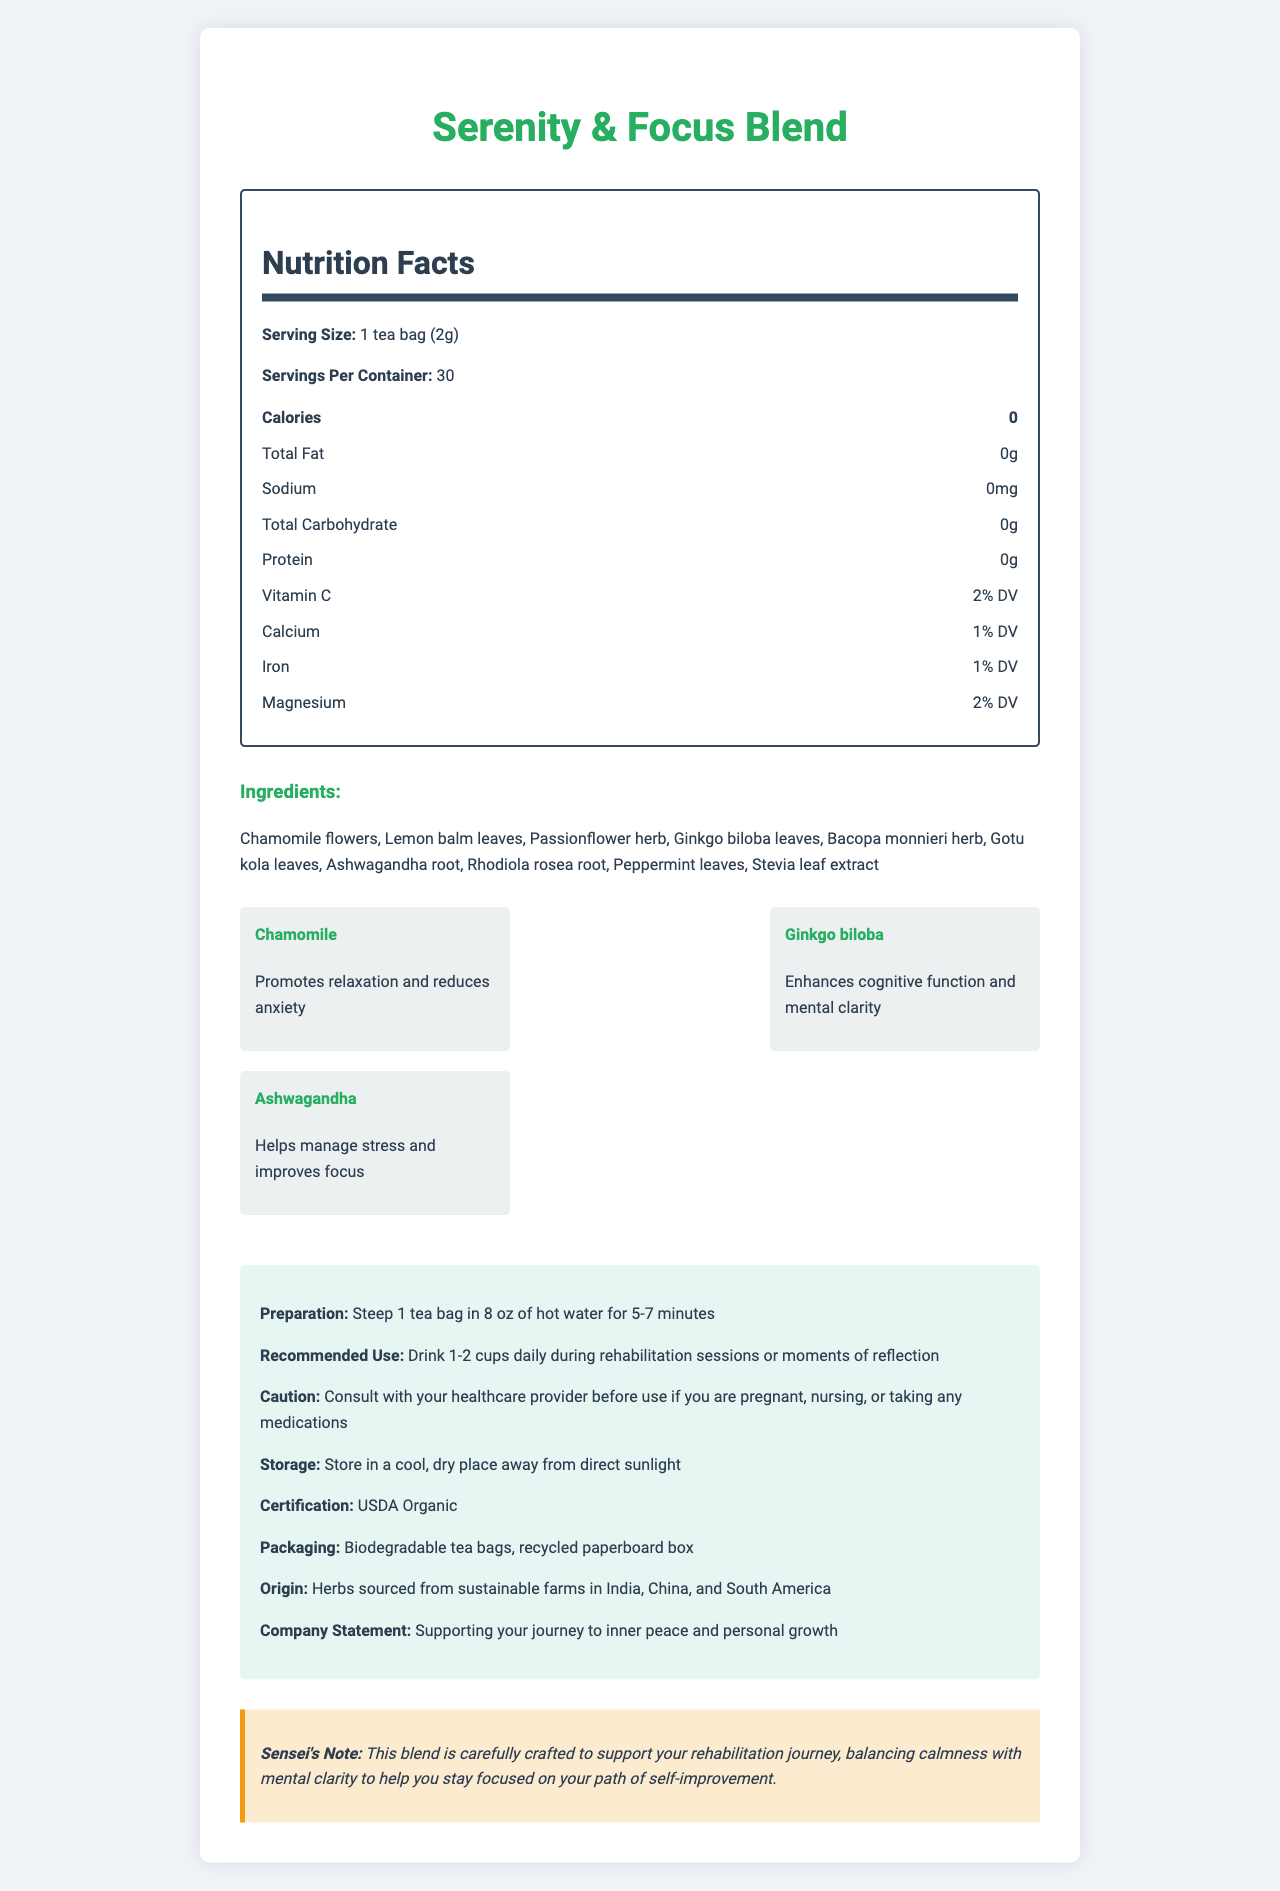How many servings are in one container of Serenity & Focus Blend? The document states that there are 30 servings per container.
Answer: 30 What is the serving size of the Serenity & Focus Blend tea? The serving size is specified in the document as 1 tea bag (2g).
Answer: 1 tea bag (2g) How many calories are in one serving of the Serenity & Focus Blend? The document lists 0 calories under the Nutrition Facts section for one serving.
Answer: 0 calories What percentage of your daily Vitamin C does one serving provide? The document indicates that one serving provides 2% of the daily value (DV) for Vitamin C.
Answer: 2% DV What is the benefit of Ginkgo biloba according to the key herbs section? The key herbs section states that Ginkgo biloba enhances cognitive function and mental clarity.
Answer: Enhances cognitive function and mental clarity Which of the following is NOT an ingredient in Serenity & Focus Blend? A. Chamomile flowers B. Lavender C. Peppermint leaves Lavender is not listed in the ingredients section, but Chamomile flowers and Peppermint leaves are.
Answer: B. Lavender What is the certification for the Serenity & Focus Blend tea? A. Fair Trade Certified B. USDA Organic C. Non-GMO Project Verified The document specifies that the blend is USDA Organic certified.
Answer: B. USDA Organic Should pregnant women consult a healthcare provider before using this tea? The document includes a caution that pregnant women should consult with their healthcare provider before using the tea.
Answer: Yes Describe the main idea of the Serenity & Focus Blend document. The document covers the tea's properties, how to prepare and use it, its ingredients and their benefits, and additional information for consumers.
Answer: The Serenity & Focus Blend document provides detailed information about a specialized herbal tea promoting calmness and mental clarity, particularly useful during rehabilitation. It includes nutritional facts, ingredients, benefits of key herbs, preparation instructions, recommended use, cautions, storage information, certification, packaging, origin, and a company statement promoting inner peace and personal growth. Why is Ashwagandha included in the Serenity & Focus Blend? The key herbs section explains that Ashwagandha helps manage stress and improves focus.
Answer: Helps manage stress and improves focus How much sodium is in one serving of this tea? The document states that there is 0 mg of sodium in one serving of the tea.
Answer: 0 mg Where are the herbs for Serenity & Focus Blend sourced from? The origin section of the document mentions that the herbs are sourced from sustainable farms in India, China, and South America.
Answer: India, China, and South America What type of packaging is used for the Serenity & Focus Blend tea bags? The packaging section states that the tea bags are biodegradable and the box is made from recycled paperboard.
Answer: Biodegradable tea bags, recycled paperboard box Can I determine the price of the Serenity & Focus Blend from this document? The document does not provide any information regarding the price of the tea.
Answer: I don't know What should you do before taking this tea if you are nursing or on medication? The caution section advises consulting with a healthcare provider before taking the tea if you are nursing or on medication.
Answer: Consult with your healthcare provider 